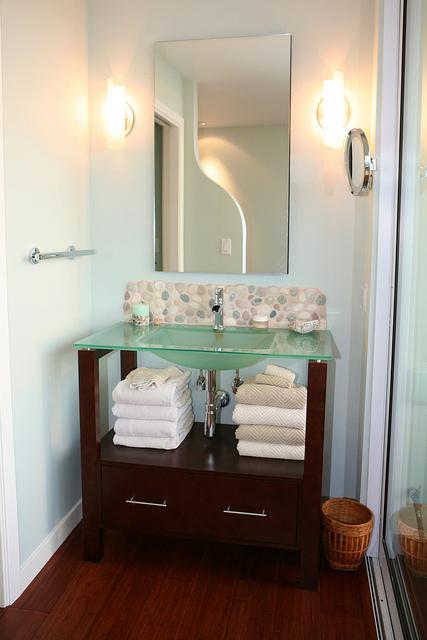Has this bathroom been modernized?
Keep it brief. Yes. How many towels are under the sink?
Short answer required. 8. Has this room been cleaned recently?
Give a very brief answer. Yes. Is the sink white?
Give a very brief answer. No. How many towels are there?
Be succinct. 8. What is on the floor next to the sink?
Short answer required. Basket. Is there toilet paper?
Write a very short answer. No. Where are the towels?
Give a very brief answer. Under sink. 